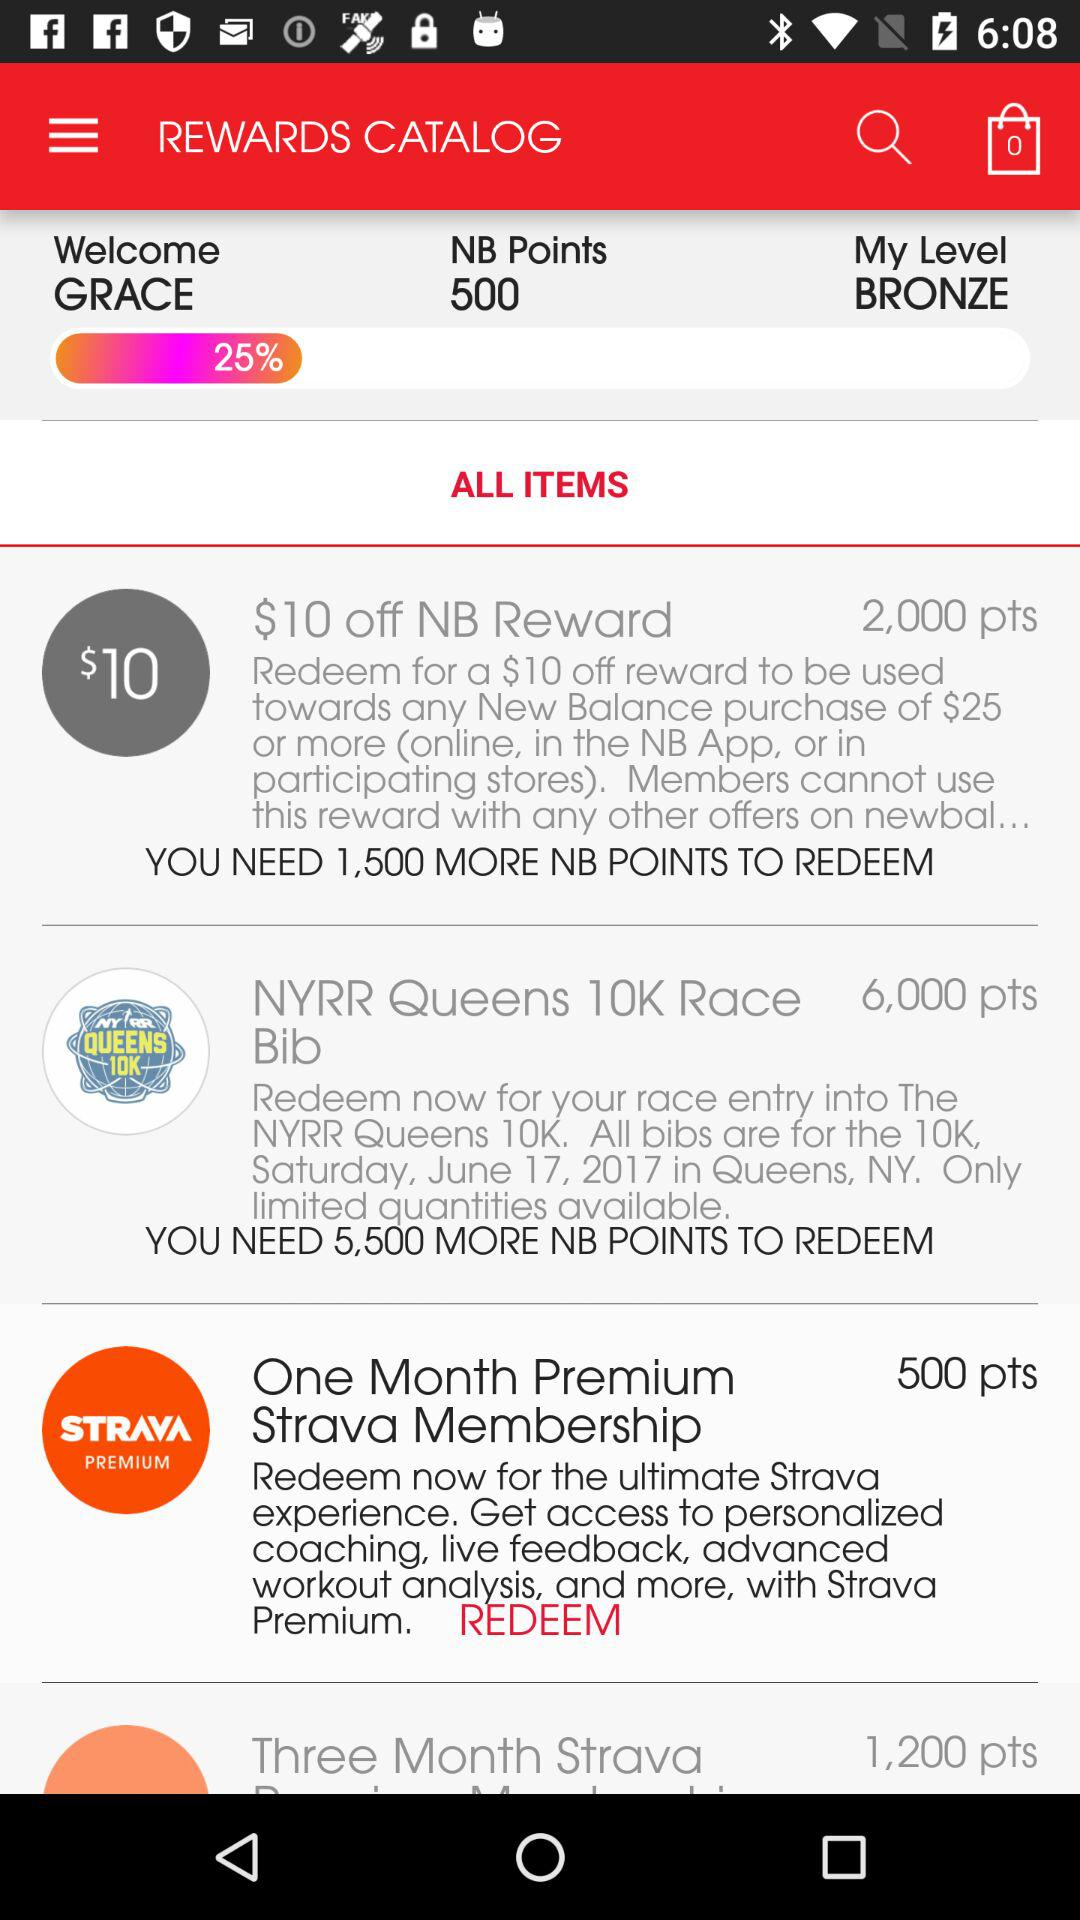How many points are required to redeem the $10 off NB Reward?
Answer the question using a single word or phrase. 2,000 